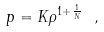<formula> <loc_0><loc_0><loc_500><loc_500>p = K \rho ^ { 1 + \frac { 1 } { N } } \ ,</formula> 